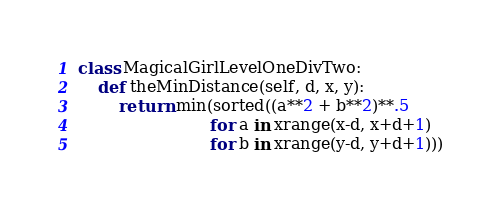Convert code to text. <code><loc_0><loc_0><loc_500><loc_500><_Python_>class MagicalGirlLevelOneDivTwo:
    def theMinDistance(self, d, x, y):
        return min(sorted((a**2 + b**2)**.5
                          for a in xrange(x-d, x+d+1)
                          for b in xrange(y-d, y+d+1)))
</code> 